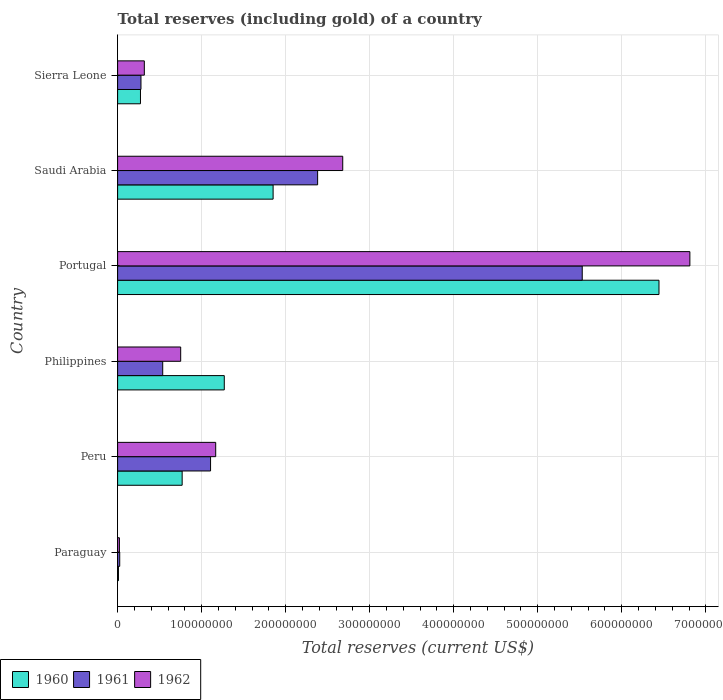How many groups of bars are there?
Offer a very short reply. 6. Are the number of bars per tick equal to the number of legend labels?
Keep it short and to the point. Yes. How many bars are there on the 1st tick from the bottom?
Ensure brevity in your answer.  3. What is the label of the 1st group of bars from the top?
Keep it short and to the point. Sierra Leone. What is the total reserves (including gold) in 1962 in Sierra Leone?
Offer a terse response. 3.18e+07. Across all countries, what is the maximum total reserves (including gold) in 1960?
Make the answer very short. 6.44e+08. Across all countries, what is the minimum total reserves (including gold) in 1961?
Offer a terse response. 2.52e+06. In which country was the total reserves (including gold) in 1961 maximum?
Your answer should be compact. Portugal. In which country was the total reserves (including gold) in 1961 minimum?
Offer a terse response. Paraguay. What is the total total reserves (including gold) in 1962 in the graph?
Your answer should be compact. 1.17e+09. What is the difference between the total reserves (including gold) in 1961 in Portugal and that in Saudi Arabia?
Offer a terse response. 3.15e+08. What is the difference between the total reserves (including gold) in 1960 in Saudi Arabia and the total reserves (including gold) in 1961 in Paraguay?
Ensure brevity in your answer.  1.83e+08. What is the average total reserves (including gold) in 1962 per country?
Keep it short and to the point. 1.96e+08. What is the difference between the total reserves (including gold) in 1960 and total reserves (including gold) in 1961 in Saudi Arabia?
Your response must be concise. -5.30e+07. In how many countries, is the total reserves (including gold) in 1961 greater than 60000000 US$?
Provide a succinct answer. 3. What is the ratio of the total reserves (including gold) in 1962 in Paraguay to that in Portugal?
Your response must be concise. 0. Is the total reserves (including gold) in 1960 in Paraguay less than that in Portugal?
Your answer should be compact. Yes. Is the difference between the total reserves (including gold) in 1960 in Portugal and Saudi Arabia greater than the difference between the total reserves (including gold) in 1961 in Portugal and Saudi Arabia?
Offer a terse response. Yes. What is the difference between the highest and the second highest total reserves (including gold) in 1961?
Give a very brief answer. 3.15e+08. What is the difference between the highest and the lowest total reserves (including gold) in 1961?
Your answer should be compact. 5.50e+08. Is the sum of the total reserves (including gold) in 1961 in Peru and Saudi Arabia greater than the maximum total reserves (including gold) in 1962 across all countries?
Your response must be concise. No. How many countries are there in the graph?
Your answer should be compact. 6. What is the difference between two consecutive major ticks on the X-axis?
Give a very brief answer. 1.00e+08. Are the values on the major ticks of X-axis written in scientific E-notation?
Your answer should be compact. No. Does the graph contain any zero values?
Keep it short and to the point. No. How many legend labels are there?
Offer a terse response. 3. What is the title of the graph?
Offer a terse response. Total reserves (including gold) of a country. Does "2001" appear as one of the legend labels in the graph?
Offer a terse response. No. What is the label or title of the X-axis?
Your answer should be compact. Total reserves (current US$). What is the Total reserves (current US$) in 1960 in Paraguay?
Give a very brief answer. 1.01e+06. What is the Total reserves (current US$) of 1961 in Paraguay?
Ensure brevity in your answer.  2.52e+06. What is the Total reserves (current US$) of 1962 in Paraguay?
Give a very brief answer. 2.14e+06. What is the Total reserves (current US$) in 1960 in Peru?
Ensure brevity in your answer.  7.68e+07. What is the Total reserves (current US$) of 1961 in Peru?
Your answer should be very brief. 1.11e+08. What is the Total reserves (current US$) of 1962 in Peru?
Your answer should be very brief. 1.17e+08. What is the Total reserves (current US$) in 1960 in Philippines?
Keep it short and to the point. 1.27e+08. What is the Total reserves (current US$) in 1961 in Philippines?
Ensure brevity in your answer.  5.37e+07. What is the Total reserves (current US$) of 1962 in Philippines?
Your answer should be very brief. 7.51e+07. What is the Total reserves (current US$) of 1960 in Portugal?
Your answer should be very brief. 6.44e+08. What is the Total reserves (current US$) of 1961 in Portugal?
Your response must be concise. 5.53e+08. What is the Total reserves (current US$) of 1962 in Portugal?
Your answer should be very brief. 6.81e+08. What is the Total reserves (current US$) in 1960 in Saudi Arabia?
Make the answer very short. 1.85e+08. What is the Total reserves (current US$) in 1961 in Saudi Arabia?
Provide a succinct answer. 2.38e+08. What is the Total reserves (current US$) in 1962 in Saudi Arabia?
Make the answer very short. 2.68e+08. What is the Total reserves (current US$) of 1960 in Sierra Leone?
Your answer should be very brief. 2.72e+07. What is the Total reserves (current US$) of 1961 in Sierra Leone?
Your answer should be compact. 2.78e+07. What is the Total reserves (current US$) in 1962 in Sierra Leone?
Give a very brief answer. 3.18e+07. Across all countries, what is the maximum Total reserves (current US$) in 1960?
Your answer should be compact. 6.44e+08. Across all countries, what is the maximum Total reserves (current US$) of 1961?
Keep it short and to the point. 5.53e+08. Across all countries, what is the maximum Total reserves (current US$) in 1962?
Your answer should be very brief. 6.81e+08. Across all countries, what is the minimum Total reserves (current US$) in 1960?
Make the answer very short. 1.01e+06. Across all countries, what is the minimum Total reserves (current US$) of 1961?
Offer a terse response. 2.52e+06. Across all countries, what is the minimum Total reserves (current US$) in 1962?
Make the answer very short. 2.14e+06. What is the total Total reserves (current US$) of 1960 in the graph?
Make the answer very short. 1.06e+09. What is the total Total reserves (current US$) in 1961 in the graph?
Your answer should be compact. 9.86e+08. What is the total Total reserves (current US$) in 1962 in the graph?
Your answer should be compact. 1.17e+09. What is the difference between the Total reserves (current US$) of 1960 in Paraguay and that in Peru?
Give a very brief answer. -7.58e+07. What is the difference between the Total reserves (current US$) of 1961 in Paraguay and that in Peru?
Your answer should be compact. -1.08e+08. What is the difference between the Total reserves (current US$) of 1962 in Paraguay and that in Peru?
Offer a terse response. -1.15e+08. What is the difference between the Total reserves (current US$) in 1960 in Paraguay and that in Philippines?
Offer a very short reply. -1.26e+08. What is the difference between the Total reserves (current US$) in 1961 in Paraguay and that in Philippines?
Your answer should be very brief. -5.12e+07. What is the difference between the Total reserves (current US$) in 1962 in Paraguay and that in Philippines?
Your answer should be compact. -7.29e+07. What is the difference between the Total reserves (current US$) of 1960 in Paraguay and that in Portugal?
Provide a short and direct response. -6.43e+08. What is the difference between the Total reserves (current US$) of 1961 in Paraguay and that in Portugal?
Offer a terse response. -5.50e+08. What is the difference between the Total reserves (current US$) in 1962 in Paraguay and that in Portugal?
Make the answer very short. -6.79e+08. What is the difference between the Total reserves (current US$) of 1960 in Paraguay and that in Saudi Arabia?
Make the answer very short. -1.84e+08. What is the difference between the Total reserves (current US$) of 1961 in Paraguay and that in Saudi Arabia?
Provide a succinct answer. -2.36e+08. What is the difference between the Total reserves (current US$) in 1962 in Paraguay and that in Saudi Arabia?
Your response must be concise. -2.66e+08. What is the difference between the Total reserves (current US$) in 1960 in Paraguay and that in Sierra Leone?
Your answer should be very brief. -2.62e+07. What is the difference between the Total reserves (current US$) in 1961 in Paraguay and that in Sierra Leone?
Your response must be concise. -2.53e+07. What is the difference between the Total reserves (current US$) in 1962 in Paraguay and that in Sierra Leone?
Your answer should be compact. -2.97e+07. What is the difference between the Total reserves (current US$) in 1960 in Peru and that in Philippines?
Ensure brevity in your answer.  -5.01e+07. What is the difference between the Total reserves (current US$) of 1961 in Peru and that in Philippines?
Your answer should be very brief. 5.69e+07. What is the difference between the Total reserves (current US$) of 1962 in Peru and that in Philippines?
Make the answer very short. 4.17e+07. What is the difference between the Total reserves (current US$) in 1960 in Peru and that in Portugal?
Provide a succinct answer. -5.67e+08. What is the difference between the Total reserves (current US$) in 1961 in Peru and that in Portugal?
Offer a terse response. -4.42e+08. What is the difference between the Total reserves (current US$) of 1962 in Peru and that in Portugal?
Make the answer very short. -5.64e+08. What is the difference between the Total reserves (current US$) of 1960 in Peru and that in Saudi Arabia?
Your response must be concise. -1.08e+08. What is the difference between the Total reserves (current US$) in 1961 in Peru and that in Saudi Arabia?
Give a very brief answer. -1.27e+08. What is the difference between the Total reserves (current US$) in 1962 in Peru and that in Saudi Arabia?
Offer a terse response. -1.51e+08. What is the difference between the Total reserves (current US$) of 1960 in Peru and that in Sierra Leone?
Your answer should be compact. 4.96e+07. What is the difference between the Total reserves (current US$) of 1961 in Peru and that in Sierra Leone?
Give a very brief answer. 8.28e+07. What is the difference between the Total reserves (current US$) of 1962 in Peru and that in Sierra Leone?
Your answer should be very brief. 8.49e+07. What is the difference between the Total reserves (current US$) of 1960 in Philippines and that in Portugal?
Your answer should be compact. -5.17e+08. What is the difference between the Total reserves (current US$) of 1961 in Philippines and that in Portugal?
Your answer should be very brief. -4.99e+08. What is the difference between the Total reserves (current US$) of 1962 in Philippines and that in Portugal?
Your answer should be compact. -6.06e+08. What is the difference between the Total reserves (current US$) in 1960 in Philippines and that in Saudi Arabia?
Your response must be concise. -5.81e+07. What is the difference between the Total reserves (current US$) in 1961 in Philippines and that in Saudi Arabia?
Offer a very short reply. -1.84e+08. What is the difference between the Total reserves (current US$) of 1962 in Philippines and that in Saudi Arabia?
Make the answer very short. -1.93e+08. What is the difference between the Total reserves (current US$) of 1960 in Philippines and that in Sierra Leone?
Your answer should be compact. 9.97e+07. What is the difference between the Total reserves (current US$) in 1961 in Philippines and that in Sierra Leone?
Provide a short and direct response. 2.59e+07. What is the difference between the Total reserves (current US$) in 1962 in Philippines and that in Sierra Leone?
Offer a very short reply. 4.33e+07. What is the difference between the Total reserves (current US$) in 1960 in Portugal and that in Saudi Arabia?
Provide a short and direct response. 4.59e+08. What is the difference between the Total reserves (current US$) in 1961 in Portugal and that in Saudi Arabia?
Provide a succinct answer. 3.15e+08. What is the difference between the Total reserves (current US$) of 1962 in Portugal and that in Saudi Arabia?
Your answer should be compact. 4.13e+08. What is the difference between the Total reserves (current US$) in 1960 in Portugal and that in Sierra Leone?
Give a very brief answer. 6.17e+08. What is the difference between the Total reserves (current US$) in 1961 in Portugal and that in Sierra Leone?
Ensure brevity in your answer.  5.25e+08. What is the difference between the Total reserves (current US$) of 1962 in Portugal and that in Sierra Leone?
Give a very brief answer. 6.49e+08. What is the difference between the Total reserves (current US$) in 1960 in Saudi Arabia and that in Sierra Leone?
Your answer should be compact. 1.58e+08. What is the difference between the Total reserves (current US$) of 1961 in Saudi Arabia and that in Sierra Leone?
Your answer should be compact. 2.10e+08. What is the difference between the Total reserves (current US$) in 1962 in Saudi Arabia and that in Sierra Leone?
Provide a short and direct response. 2.36e+08. What is the difference between the Total reserves (current US$) in 1960 in Paraguay and the Total reserves (current US$) in 1961 in Peru?
Provide a short and direct response. -1.10e+08. What is the difference between the Total reserves (current US$) of 1960 in Paraguay and the Total reserves (current US$) of 1962 in Peru?
Keep it short and to the point. -1.16e+08. What is the difference between the Total reserves (current US$) of 1961 in Paraguay and the Total reserves (current US$) of 1962 in Peru?
Give a very brief answer. -1.14e+08. What is the difference between the Total reserves (current US$) of 1960 in Paraguay and the Total reserves (current US$) of 1961 in Philippines?
Keep it short and to the point. -5.27e+07. What is the difference between the Total reserves (current US$) of 1960 in Paraguay and the Total reserves (current US$) of 1962 in Philippines?
Keep it short and to the point. -7.41e+07. What is the difference between the Total reserves (current US$) in 1961 in Paraguay and the Total reserves (current US$) in 1962 in Philippines?
Ensure brevity in your answer.  -7.25e+07. What is the difference between the Total reserves (current US$) in 1960 in Paraguay and the Total reserves (current US$) in 1961 in Portugal?
Make the answer very short. -5.52e+08. What is the difference between the Total reserves (current US$) in 1960 in Paraguay and the Total reserves (current US$) in 1962 in Portugal?
Your response must be concise. -6.80e+08. What is the difference between the Total reserves (current US$) of 1961 in Paraguay and the Total reserves (current US$) of 1962 in Portugal?
Make the answer very short. -6.79e+08. What is the difference between the Total reserves (current US$) in 1960 in Paraguay and the Total reserves (current US$) in 1961 in Saudi Arabia?
Your answer should be very brief. -2.37e+08. What is the difference between the Total reserves (current US$) of 1960 in Paraguay and the Total reserves (current US$) of 1962 in Saudi Arabia?
Your response must be concise. -2.67e+08. What is the difference between the Total reserves (current US$) in 1961 in Paraguay and the Total reserves (current US$) in 1962 in Saudi Arabia?
Provide a short and direct response. -2.65e+08. What is the difference between the Total reserves (current US$) of 1960 in Paraguay and the Total reserves (current US$) of 1961 in Sierra Leone?
Provide a short and direct response. -2.68e+07. What is the difference between the Total reserves (current US$) in 1960 in Paraguay and the Total reserves (current US$) in 1962 in Sierra Leone?
Ensure brevity in your answer.  -3.08e+07. What is the difference between the Total reserves (current US$) of 1961 in Paraguay and the Total reserves (current US$) of 1962 in Sierra Leone?
Your answer should be compact. -2.93e+07. What is the difference between the Total reserves (current US$) of 1960 in Peru and the Total reserves (current US$) of 1961 in Philippines?
Your response must be concise. 2.31e+07. What is the difference between the Total reserves (current US$) of 1960 in Peru and the Total reserves (current US$) of 1962 in Philippines?
Offer a terse response. 1.74e+06. What is the difference between the Total reserves (current US$) of 1961 in Peru and the Total reserves (current US$) of 1962 in Philippines?
Offer a very short reply. 3.56e+07. What is the difference between the Total reserves (current US$) in 1960 in Peru and the Total reserves (current US$) in 1961 in Portugal?
Keep it short and to the point. -4.76e+08. What is the difference between the Total reserves (current US$) of 1960 in Peru and the Total reserves (current US$) of 1962 in Portugal?
Offer a very short reply. -6.04e+08. What is the difference between the Total reserves (current US$) of 1961 in Peru and the Total reserves (current US$) of 1962 in Portugal?
Your answer should be very brief. -5.70e+08. What is the difference between the Total reserves (current US$) in 1960 in Peru and the Total reserves (current US$) in 1961 in Saudi Arabia?
Your response must be concise. -1.61e+08. What is the difference between the Total reserves (current US$) in 1960 in Peru and the Total reserves (current US$) in 1962 in Saudi Arabia?
Offer a terse response. -1.91e+08. What is the difference between the Total reserves (current US$) of 1961 in Peru and the Total reserves (current US$) of 1962 in Saudi Arabia?
Your answer should be compact. -1.57e+08. What is the difference between the Total reserves (current US$) of 1960 in Peru and the Total reserves (current US$) of 1961 in Sierra Leone?
Your answer should be very brief. 4.90e+07. What is the difference between the Total reserves (current US$) in 1960 in Peru and the Total reserves (current US$) in 1962 in Sierra Leone?
Provide a succinct answer. 4.50e+07. What is the difference between the Total reserves (current US$) in 1961 in Peru and the Total reserves (current US$) in 1962 in Sierra Leone?
Make the answer very short. 7.88e+07. What is the difference between the Total reserves (current US$) in 1960 in Philippines and the Total reserves (current US$) in 1961 in Portugal?
Provide a succinct answer. -4.26e+08. What is the difference between the Total reserves (current US$) in 1960 in Philippines and the Total reserves (current US$) in 1962 in Portugal?
Make the answer very short. -5.54e+08. What is the difference between the Total reserves (current US$) in 1961 in Philippines and the Total reserves (current US$) in 1962 in Portugal?
Keep it short and to the point. -6.27e+08. What is the difference between the Total reserves (current US$) in 1960 in Philippines and the Total reserves (current US$) in 1961 in Saudi Arabia?
Offer a terse response. -1.11e+08. What is the difference between the Total reserves (current US$) of 1960 in Philippines and the Total reserves (current US$) of 1962 in Saudi Arabia?
Offer a very short reply. -1.41e+08. What is the difference between the Total reserves (current US$) in 1961 in Philippines and the Total reserves (current US$) in 1962 in Saudi Arabia?
Make the answer very short. -2.14e+08. What is the difference between the Total reserves (current US$) of 1960 in Philippines and the Total reserves (current US$) of 1961 in Sierra Leone?
Give a very brief answer. 9.91e+07. What is the difference between the Total reserves (current US$) of 1960 in Philippines and the Total reserves (current US$) of 1962 in Sierra Leone?
Give a very brief answer. 9.51e+07. What is the difference between the Total reserves (current US$) in 1961 in Philippines and the Total reserves (current US$) in 1962 in Sierra Leone?
Offer a terse response. 2.19e+07. What is the difference between the Total reserves (current US$) in 1960 in Portugal and the Total reserves (current US$) in 1961 in Saudi Arabia?
Your response must be concise. 4.06e+08. What is the difference between the Total reserves (current US$) in 1960 in Portugal and the Total reserves (current US$) in 1962 in Saudi Arabia?
Provide a short and direct response. 3.76e+08. What is the difference between the Total reserves (current US$) of 1961 in Portugal and the Total reserves (current US$) of 1962 in Saudi Arabia?
Offer a terse response. 2.85e+08. What is the difference between the Total reserves (current US$) of 1960 in Portugal and the Total reserves (current US$) of 1961 in Sierra Leone?
Your answer should be very brief. 6.16e+08. What is the difference between the Total reserves (current US$) of 1960 in Portugal and the Total reserves (current US$) of 1962 in Sierra Leone?
Provide a short and direct response. 6.12e+08. What is the difference between the Total reserves (current US$) of 1961 in Portugal and the Total reserves (current US$) of 1962 in Sierra Leone?
Make the answer very short. 5.21e+08. What is the difference between the Total reserves (current US$) in 1960 in Saudi Arabia and the Total reserves (current US$) in 1961 in Sierra Leone?
Offer a terse response. 1.57e+08. What is the difference between the Total reserves (current US$) in 1960 in Saudi Arabia and the Total reserves (current US$) in 1962 in Sierra Leone?
Your answer should be very brief. 1.53e+08. What is the difference between the Total reserves (current US$) in 1961 in Saudi Arabia and the Total reserves (current US$) in 1962 in Sierra Leone?
Offer a terse response. 2.06e+08. What is the average Total reserves (current US$) in 1960 per country?
Offer a terse response. 1.77e+08. What is the average Total reserves (current US$) of 1961 per country?
Make the answer very short. 1.64e+08. What is the average Total reserves (current US$) in 1962 per country?
Give a very brief answer. 1.96e+08. What is the difference between the Total reserves (current US$) in 1960 and Total reserves (current US$) in 1961 in Paraguay?
Ensure brevity in your answer.  -1.51e+06. What is the difference between the Total reserves (current US$) of 1960 and Total reserves (current US$) of 1962 in Paraguay?
Your answer should be compact. -1.13e+06. What is the difference between the Total reserves (current US$) in 1961 and Total reserves (current US$) in 1962 in Paraguay?
Provide a succinct answer. 3.80e+05. What is the difference between the Total reserves (current US$) in 1960 and Total reserves (current US$) in 1961 in Peru?
Your answer should be compact. -3.38e+07. What is the difference between the Total reserves (current US$) in 1960 and Total reserves (current US$) in 1962 in Peru?
Keep it short and to the point. -3.99e+07. What is the difference between the Total reserves (current US$) of 1961 and Total reserves (current US$) of 1962 in Peru?
Your answer should be very brief. -6.11e+06. What is the difference between the Total reserves (current US$) in 1960 and Total reserves (current US$) in 1961 in Philippines?
Give a very brief answer. 7.33e+07. What is the difference between the Total reserves (current US$) in 1960 and Total reserves (current US$) in 1962 in Philippines?
Your answer should be compact. 5.19e+07. What is the difference between the Total reserves (current US$) of 1961 and Total reserves (current US$) of 1962 in Philippines?
Your response must be concise. -2.14e+07. What is the difference between the Total reserves (current US$) in 1960 and Total reserves (current US$) in 1961 in Portugal?
Your answer should be compact. 9.13e+07. What is the difference between the Total reserves (current US$) of 1960 and Total reserves (current US$) of 1962 in Portugal?
Offer a very short reply. -3.68e+07. What is the difference between the Total reserves (current US$) in 1961 and Total reserves (current US$) in 1962 in Portugal?
Your answer should be compact. -1.28e+08. What is the difference between the Total reserves (current US$) of 1960 and Total reserves (current US$) of 1961 in Saudi Arabia?
Offer a terse response. -5.30e+07. What is the difference between the Total reserves (current US$) in 1960 and Total reserves (current US$) in 1962 in Saudi Arabia?
Offer a very short reply. -8.29e+07. What is the difference between the Total reserves (current US$) in 1961 and Total reserves (current US$) in 1962 in Saudi Arabia?
Make the answer very short. -2.99e+07. What is the difference between the Total reserves (current US$) in 1960 and Total reserves (current US$) in 1961 in Sierra Leone?
Your answer should be very brief. -6.00e+05. What is the difference between the Total reserves (current US$) of 1960 and Total reserves (current US$) of 1962 in Sierra Leone?
Your answer should be very brief. -4.60e+06. What is the difference between the Total reserves (current US$) in 1961 and Total reserves (current US$) in 1962 in Sierra Leone?
Keep it short and to the point. -4.00e+06. What is the ratio of the Total reserves (current US$) of 1960 in Paraguay to that in Peru?
Provide a succinct answer. 0.01. What is the ratio of the Total reserves (current US$) of 1961 in Paraguay to that in Peru?
Offer a terse response. 0.02. What is the ratio of the Total reserves (current US$) of 1962 in Paraguay to that in Peru?
Your response must be concise. 0.02. What is the ratio of the Total reserves (current US$) in 1960 in Paraguay to that in Philippines?
Your response must be concise. 0.01. What is the ratio of the Total reserves (current US$) of 1961 in Paraguay to that in Philippines?
Offer a very short reply. 0.05. What is the ratio of the Total reserves (current US$) of 1962 in Paraguay to that in Philippines?
Provide a short and direct response. 0.03. What is the ratio of the Total reserves (current US$) in 1960 in Paraguay to that in Portugal?
Offer a very short reply. 0. What is the ratio of the Total reserves (current US$) in 1961 in Paraguay to that in Portugal?
Provide a short and direct response. 0. What is the ratio of the Total reserves (current US$) of 1962 in Paraguay to that in Portugal?
Give a very brief answer. 0. What is the ratio of the Total reserves (current US$) in 1960 in Paraguay to that in Saudi Arabia?
Ensure brevity in your answer.  0.01. What is the ratio of the Total reserves (current US$) in 1961 in Paraguay to that in Saudi Arabia?
Ensure brevity in your answer.  0.01. What is the ratio of the Total reserves (current US$) in 1962 in Paraguay to that in Saudi Arabia?
Offer a terse response. 0.01. What is the ratio of the Total reserves (current US$) in 1960 in Paraguay to that in Sierra Leone?
Your response must be concise. 0.04. What is the ratio of the Total reserves (current US$) in 1961 in Paraguay to that in Sierra Leone?
Ensure brevity in your answer.  0.09. What is the ratio of the Total reserves (current US$) of 1962 in Paraguay to that in Sierra Leone?
Make the answer very short. 0.07. What is the ratio of the Total reserves (current US$) of 1960 in Peru to that in Philippines?
Your answer should be compact. 0.61. What is the ratio of the Total reserves (current US$) of 1961 in Peru to that in Philippines?
Provide a succinct answer. 2.06. What is the ratio of the Total reserves (current US$) in 1962 in Peru to that in Philippines?
Your answer should be compact. 1.56. What is the ratio of the Total reserves (current US$) of 1960 in Peru to that in Portugal?
Your answer should be compact. 0.12. What is the ratio of the Total reserves (current US$) of 1961 in Peru to that in Portugal?
Provide a succinct answer. 0.2. What is the ratio of the Total reserves (current US$) in 1962 in Peru to that in Portugal?
Make the answer very short. 0.17. What is the ratio of the Total reserves (current US$) in 1960 in Peru to that in Saudi Arabia?
Provide a short and direct response. 0.42. What is the ratio of the Total reserves (current US$) of 1961 in Peru to that in Saudi Arabia?
Give a very brief answer. 0.46. What is the ratio of the Total reserves (current US$) of 1962 in Peru to that in Saudi Arabia?
Ensure brevity in your answer.  0.44. What is the ratio of the Total reserves (current US$) in 1960 in Peru to that in Sierra Leone?
Offer a terse response. 2.82. What is the ratio of the Total reserves (current US$) in 1961 in Peru to that in Sierra Leone?
Provide a short and direct response. 3.98. What is the ratio of the Total reserves (current US$) in 1962 in Peru to that in Sierra Leone?
Your answer should be compact. 3.67. What is the ratio of the Total reserves (current US$) in 1960 in Philippines to that in Portugal?
Keep it short and to the point. 0.2. What is the ratio of the Total reserves (current US$) of 1961 in Philippines to that in Portugal?
Your answer should be very brief. 0.1. What is the ratio of the Total reserves (current US$) in 1962 in Philippines to that in Portugal?
Keep it short and to the point. 0.11. What is the ratio of the Total reserves (current US$) in 1960 in Philippines to that in Saudi Arabia?
Provide a short and direct response. 0.69. What is the ratio of the Total reserves (current US$) of 1961 in Philippines to that in Saudi Arabia?
Make the answer very short. 0.23. What is the ratio of the Total reserves (current US$) of 1962 in Philippines to that in Saudi Arabia?
Keep it short and to the point. 0.28. What is the ratio of the Total reserves (current US$) in 1960 in Philippines to that in Sierra Leone?
Keep it short and to the point. 4.67. What is the ratio of the Total reserves (current US$) of 1961 in Philippines to that in Sierra Leone?
Offer a very short reply. 1.93. What is the ratio of the Total reserves (current US$) of 1962 in Philippines to that in Sierra Leone?
Your response must be concise. 2.36. What is the ratio of the Total reserves (current US$) of 1960 in Portugal to that in Saudi Arabia?
Your answer should be compact. 3.48. What is the ratio of the Total reserves (current US$) of 1961 in Portugal to that in Saudi Arabia?
Provide a short and direct response. 2.32. What is the ratio of the Total reserves (current US$) in 1962 in Portugal to that in Saudi Arabia?
Provide a short and direct response. 2.54. What is the ratio of the Total reserves (current US$) in 1960 in Portugal to that in Sierra Leone?
Your response must be concise. 23.69. What is the ratio of the Total reserves (current US$) in 1961 in Portugal to that in Sierra Leone?
Ensure brevity in your answer.  19.89. What is the ratio of the Total reserves (current US$) of 1962 in Portugal to that in Sierra Leone?
Offer a terse response. 21.42. What is the ratio of the Total reserves (current US$) in 1960 in Saudi Arabia to that in Sierra Leone?
Offer a very short reply. 6.8. What is the ratio of the Total reserves (current US$) of 1961 in Saudi Arabia to that in Sierra Leone?
Your response must be concise. 8.56. What is the ratio of the Total reserves (current US$) in 1962 in Saudi Arabia to that in Sierra Leone?
Your answer should be very brief. 8.43. What is the difference between the highest and the second highest Total reserves (current US$) of 1960?
Provide a short and direct response. 4.59e+08. What is the difference between the highest and the second highest Total reserves (current US$) of 1961?
Provide a short and direct response. 3.15e+08. What is the difference between the highest and the second highest Total reserves (current US$) in 1962?
Provide a short and direct response. 4.13e+08. What is the difference between the highest and the lowest Total reserves (current US$) in 1960?
Your response must be concise. 6.43e+08. What is the difference between the highest and the lowest Total reserves (current US$) of 1961?
Keep it short and to the point. 5.50e+08. What is the difference between the highest and the lowest Total reserves (current US$) in 1962?
Ensure brevity in your answer.  6.79e+08. 